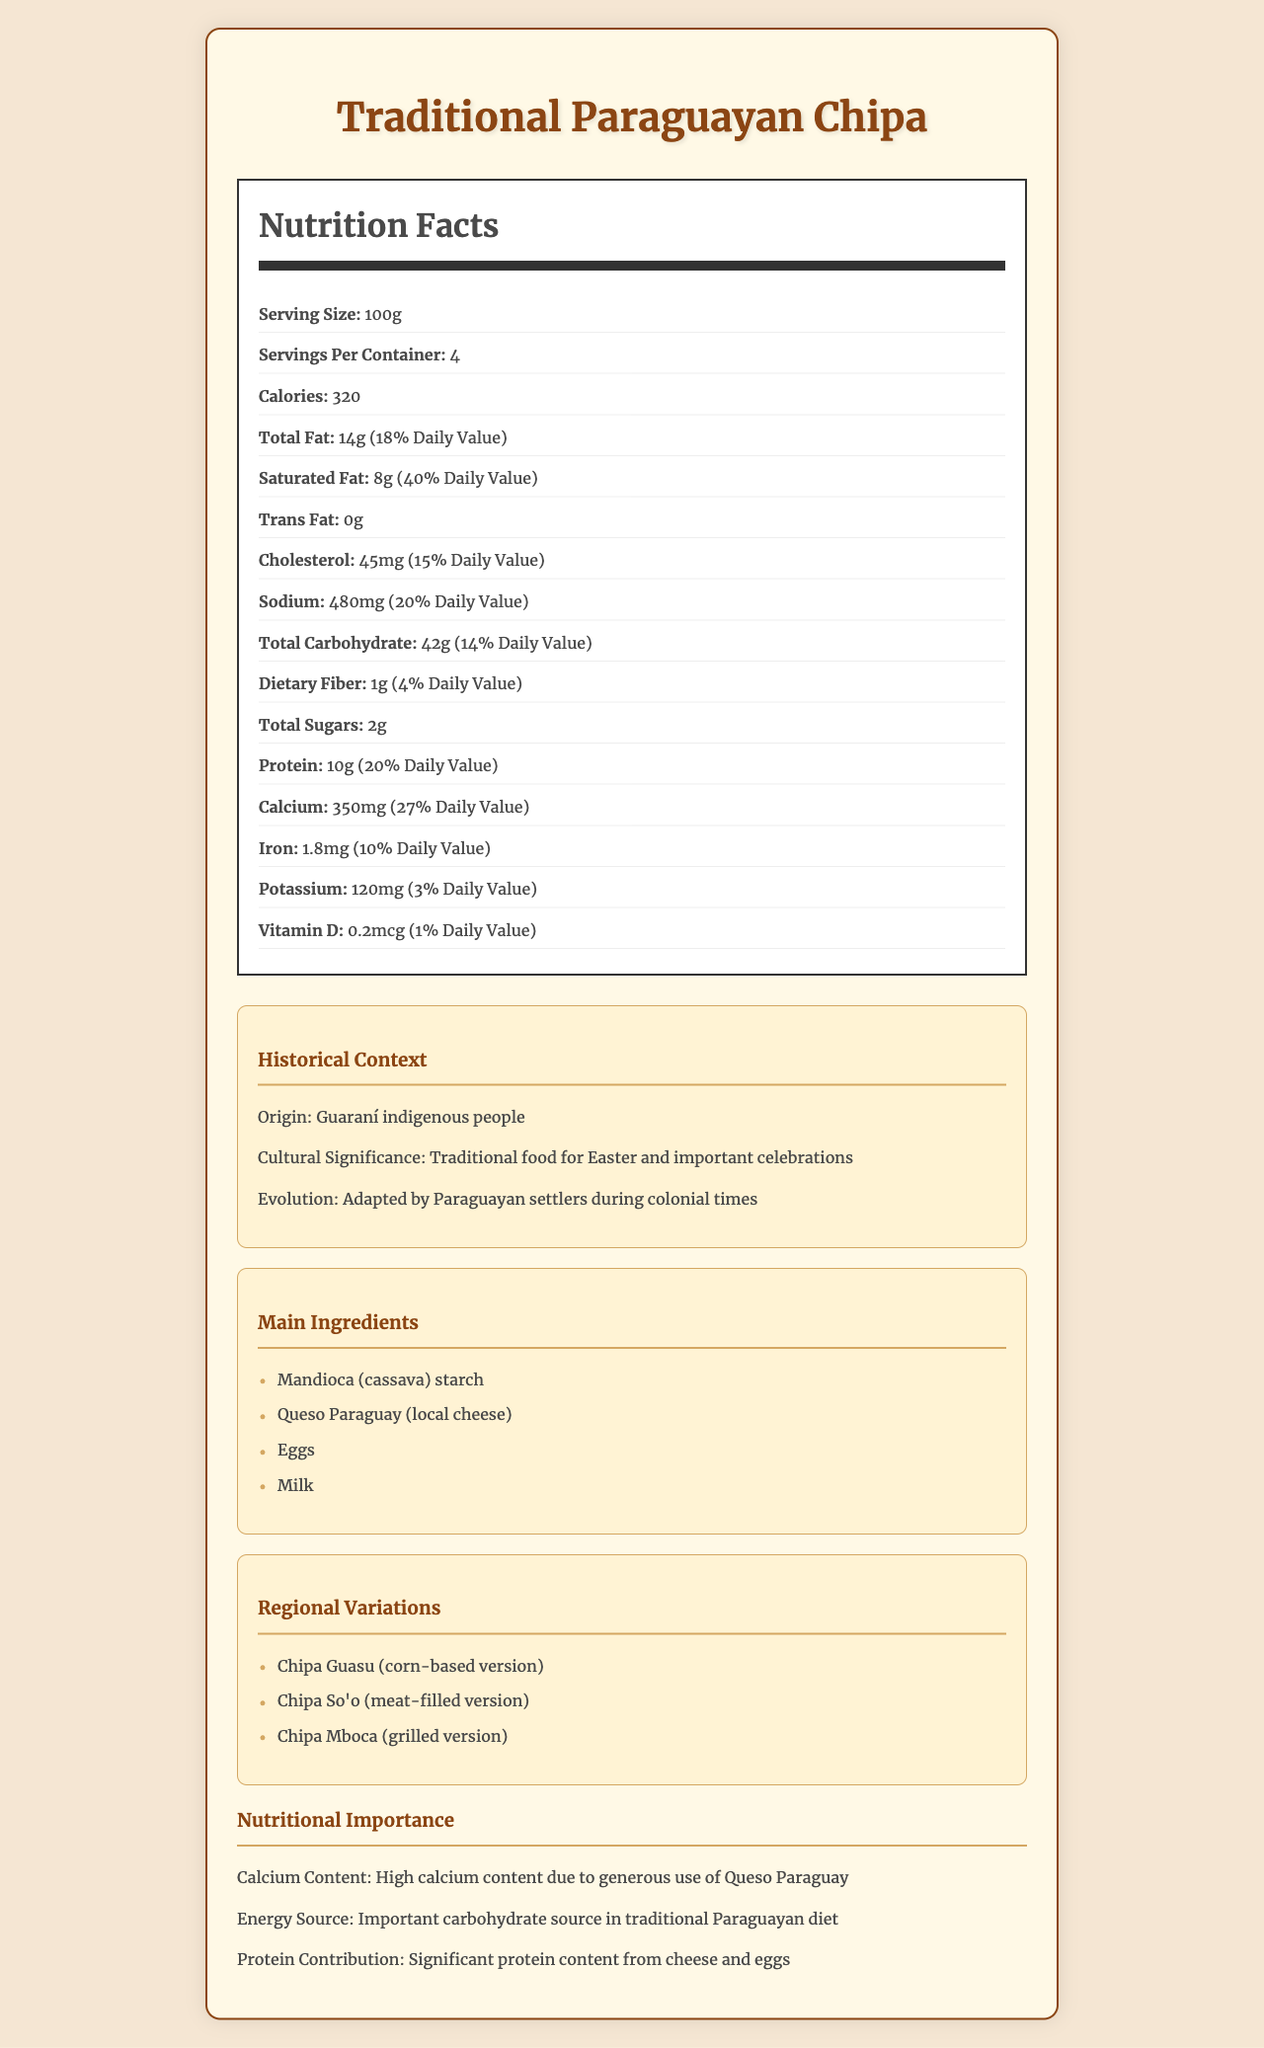what is the serving size for Traditional Paraguayan Chipa? The document lists the serving size as 100g under the nutrition label section.
Answer: 100g how many calories does one serving of Traditional Paraguayan Chipa contain? The calories per serving are indicated as 320 in the nutrition label section.
Answer: 320 what is the percentage of the daily value for calcium in Traditional Paraguayan Chipa? The document states that the daily value for calcium is 27% for one serving.
Answer: 27% what contributes most significantly to the high calcium content in Traditional Paraguayan Chipa? The document mentions that the high calcium content is mainly due to the generous use of Queso Paraguay.
Answer: Queso Paraguay (local cheese) list the main ingredients of Traditional Paraguayan Chipa. The ingredients are listed under the "Main Ingredients" section.
Answer: Mandioca (cassava) starch, Queso Paraguay (local cheese), Eggs, Milk which of the following is not a regional variation of Chipa? I. Chipa Guasu II. Chipa So'o III. Chipa Mboca IV. Chipa Moroti The regional variations listed in the document are Chipa Guasu, Chipa So'o, and Chipa Mboca. Chipa Moroti is not listed.
Answer: IV. Chipa Moroti how much protein is in one serving of Traditional Paraguayan Chipa? A. 8g B. 10g C. 12g D. 14g The protein content is indicated as 10g per serving in the nutrition label.
Answer: B. 10g is Traditional Paraguayan Chipa a significant source of dietary fiber? The dietary fiber content is only 1g per serving, which is 4% of the daily value, not significant.
Answer: No what is the historical origin of Traditional Paraguayan Chipa? The origin is stated as the Guaraní indigenous people in the historical context section.
Answer: Guaraní indigenous people in which celebrations is Traditional Paraguayan Chipa culturally significant? The document mentions it is a traditional food for Easter and other important celebrations.
Answer: Easter and important celebrations summarize the nutritional importance of Traditional Paraguayan Chipa. The nutritional importance includes high calcium content, significant protein from cheese and eggs, and being a carbohydrate source in the Paraguayan diet.
Answer: High in calcium, significant protein content, important carbohydrate source what is the daily value percentage for iron in Traditional Paraguayan Chipa? The document mentions the daily value percentage for iron is 10%.
Answer: 10% how many servings are in one container of Traditional Paraguayan Chipa? The number of servings per container is listed as 4 in the nutrition label.
Answer: 4 how much Vitamin D is in one serving of Traditional Paraguayan Chipa? The amount of Vitamin D per serving is listed as 0.2 mcg.
Answer: 0.2 mcg list the main ingredients of Traditional Paraguayan Chipa and their contributions to its nutritional content. Mandioca starch contributes carbohydrates, Queso Paraguay is the main source of calcium and protein, eggs provide protein and additional calcium, and milk offers calcium and some protein.
Answer: Mandioca (cassava) starch, Queso Paraguay (local cheese), Eggs, Milk what cultural significance does Traditional Paraguayan Chipa hold? The document states that it is traditionally consumed during Easter and important celebrations.
Answer: Traditional food for Easter and important celebrations describe the origin and evolution of Traditional Paraguayan Chipa. The historical context section indicates that it originated from Guaraní people and was adapted during colonial times.
Answer: Originated from Guaraní indigenous people, adapted by Paraguayan settlers during colonial times which nutrient is present in the largest amount in Traditional Paraguayan Chipa? A. Total Fat B. Protein C. Total Carbohydrate D. Sodium The total carbohydrate amount is 42g, which is the highest among the listed options.
Answer: C. Total Carbohydrate is Traditional Paraguayan Chipa suitable for someone who needs a diet free of trans fat? The document lists the trans fat content as 0g per serving.
Answer: Yes what is the primary source of calcium in Traditional Paraguayan Chipa? The document mentions Queso Paraguay as the primary source of calcium.
Answer: Queso Paraguay (local cheese) 